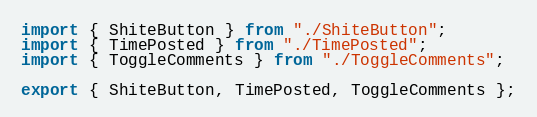<code> <loc_0><loc_0><loc_500><loc_500><_TypeScript_>import { ShiteButton } from "./ShiteButton";
import { TimePosted } from "./TimePosted";
import { ToggleComments } from "./ToggleComments";

export { ShiteButton, TimePosted, ToggleComments };

</code> 